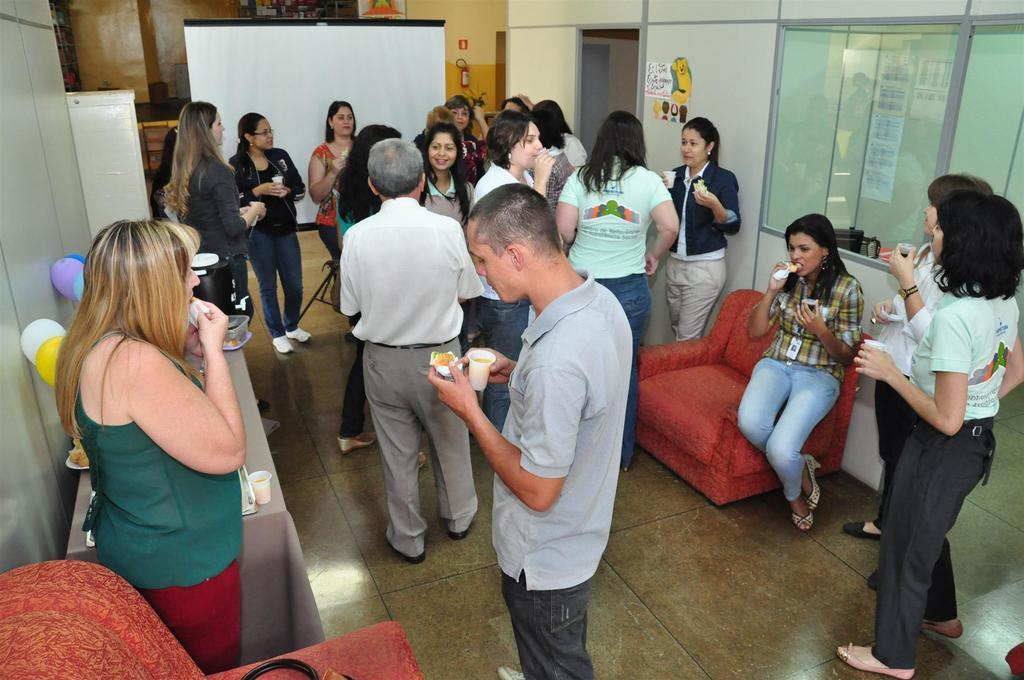How many people are in the group visible in the image? There is a group of people in the image, but the exact number cannot be determined from the provided facts. What type of surface is under the group of people? There is a floor in the image, which is likely the surface under the group of people. What type of furniture is present in the image? There are sofas and a table in the image. What is placed on the table in the image? There is a cloth and a cup on the table in the image. What type of decorations are present in the image? There are balloons in the image. What type of glasses are visible in the image? There are glasses in the image, but the type cannot be determined from the provided facts. What is hanging on the wall in the image? There is a poster in the image, which is likely hanging on the wall. What type of safety equipment is present in the image? There is a fire extinguisher in the image. What type of screen is visible in the image? There is a screen in the image, but the type cannot be determined from the provided facts. What type of wall is present in the image? There is a wall in the image, but the type cannot be determined from the provided facts. How does the ball increase in size throughout the year in the image? There is no ball present in the image, so it cannot be determined how it might increase in size throughout the year. 